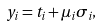<formula> <loc_0><loc_0><loc_500><loc_500>y _ { i } = t _ { i } + \mu _ { i } \sigma _ { i } ,</formula> 